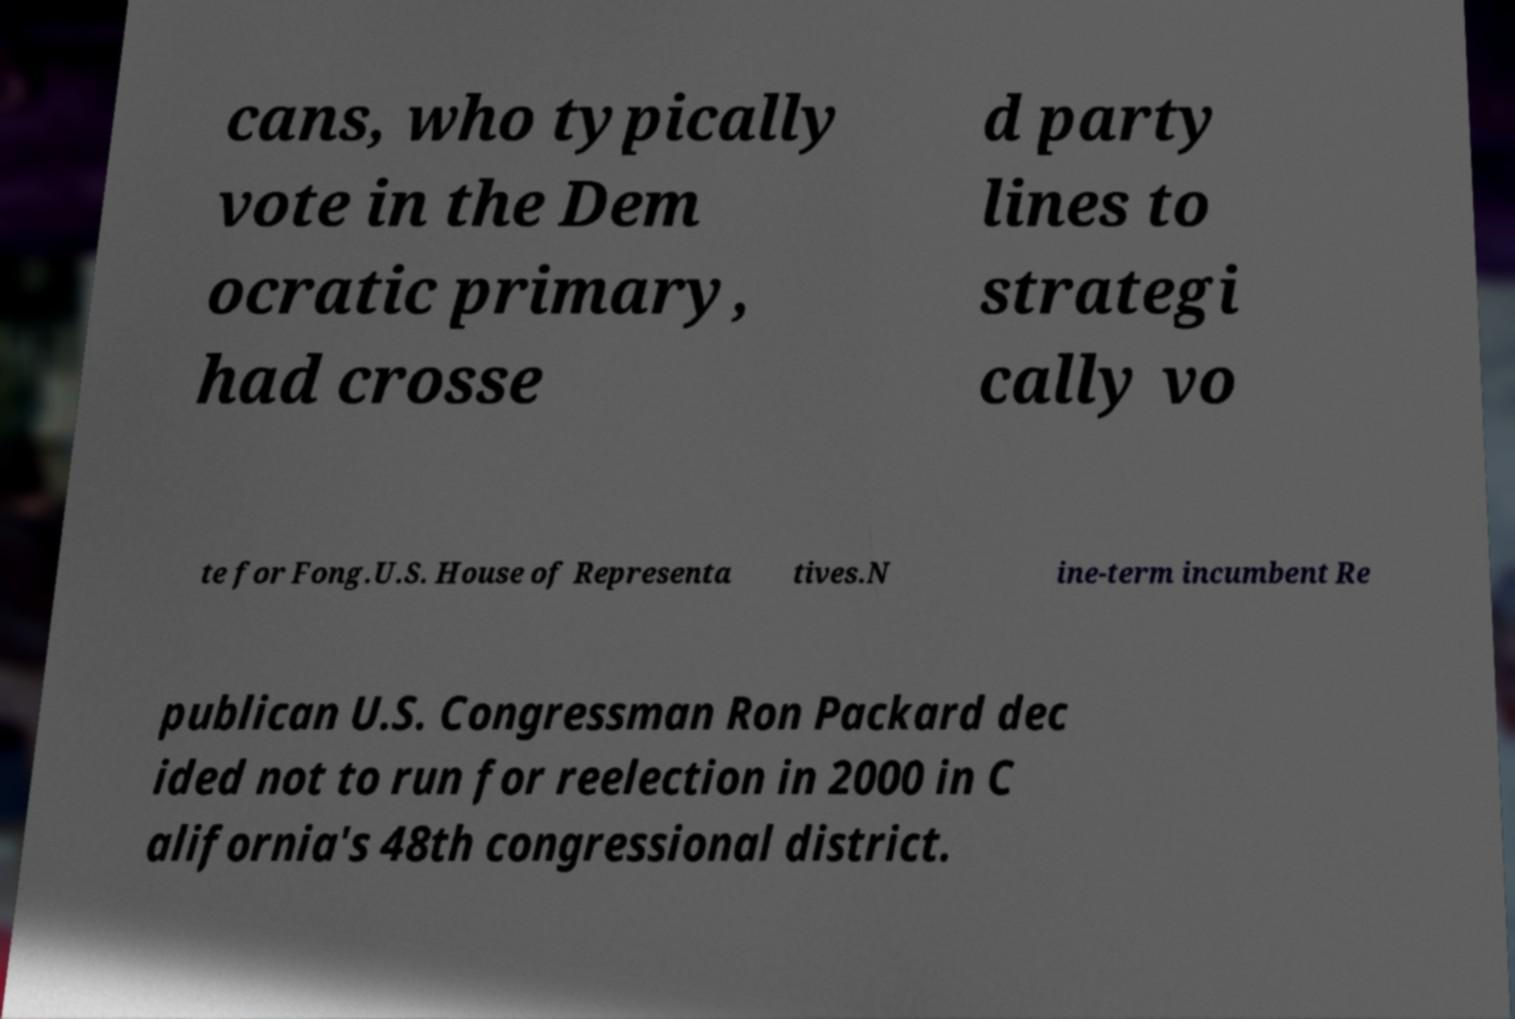Can you accurately transcribe the text from the provided image for me? cans, who typically vote in the Dem ocratic primary, had crosse d party lines to strategi cally vo te for Fong.U.S. House of Representa tives.N ine-term incumbent Re publican U.S. Congressman Ron Packard dec ided not to run for reelection in 2000 in C alifornia's 48th congressional district. 